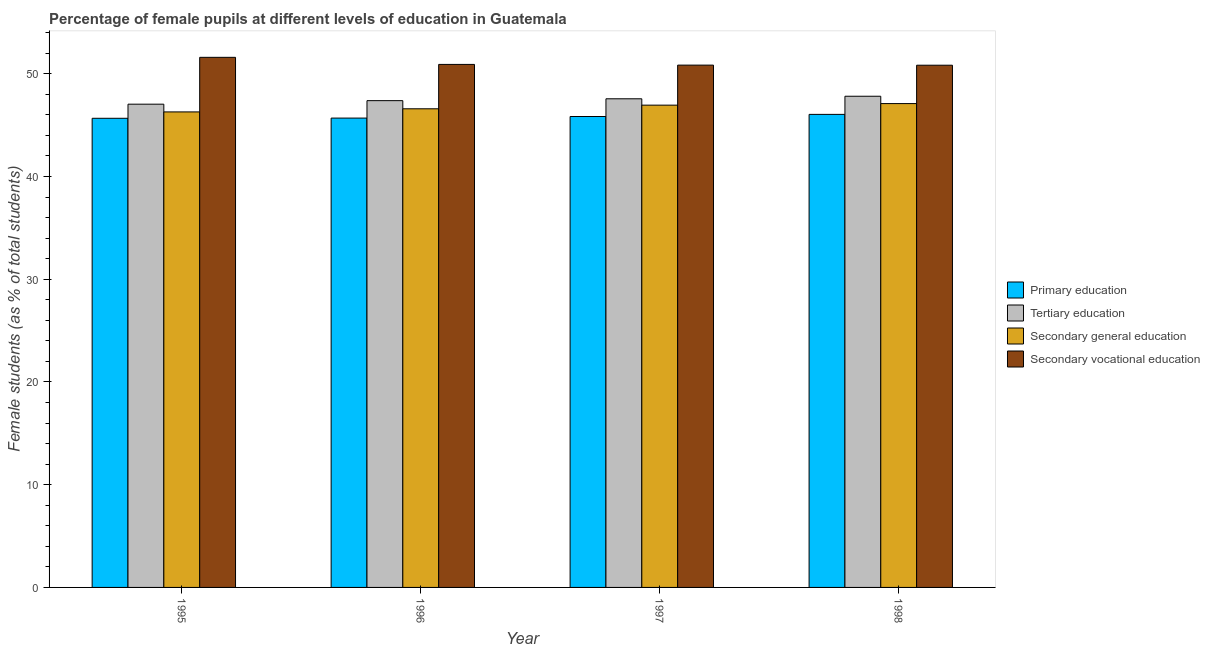How many different coloured bars are there?
Make the answer very short. 4. How many groups of bars are there?
Provide a succinct answer. 4. Are the number of bars on each tick of the X-axis equal?
Provide a short and direct response. Yes. How many bars are there on the 1st tick from the left?
Give a very brief answer. 4. What is the label of the 4th group of bars from the left?
Offer a terse response. 1998. In how many cases, is the number of bars for a given year not equal to the number of legend labels?
Provide a short and direct response. 0. What is the percentage of female students in primary education in 1997?
Ensure brevity in your answer.  45.84. Across all years, what is the maximum percentage of female students in secondary vocational education?
Ensure brevity in your answer.  51.6. Across all years, what is the minimum percentage of female students in tertiary education?
Offer a very short reply. 47.04. In which year was the percentage of female students in primary education minimum?
Make the answer very short. 1995. What is the total percentage of female students in tertiary education in the graph?
Ensure brevity in your answer.  189.8. What is the difference between the percentage of female students in tertiary education in 1995 and that in 1996?
Ensure brevity in your answer.  -0.34. What is the difference between the percentage of female students in secondary education in 1995 and the percentage of female students in tertiary education in 1996?
Ensure brevity in your answer.  -0.3. What is the average percentage of female students in primary education per year?
Your response must be concise. 45.81. In how many years, is the percentage of female students in tertiary education greater than 42 %?
Your answer should be very brief. 4. What is the ratio of the percentage of female students in secondary vocational education in 1995 to that in 1997?
Your answer should be very brief. 1.01. Is the difference between the percentage of female students in tertiary education in 1995 and 1996 greater than the difference between the percentage of female students in secondary vocational education in 1995 and 1996?
Your response must be concise. No. What is the difference between the highest and the second highest percentage of female students in secondary education?
Your answer should be compact. 0.15. What is the difference between the highest and the lowest percentage of female students in primary education?
Your response must be concise. 0.38. In how many years, is the percentage of female students in secondary vocational education greater than the average percentage of female students in secondary vocational education taken over all years?
Ensure brevity in your answer.  1. Is it the case that in every year, the sum of the percentage of female students in secondary vocational education and percentage of female students in tertiary education is greater than the sum of percentage of female students in primary education and percentage of female students in secondary education?
Offer a terse response. Yes. What does the 1st bar from the left in 1997 represents?
Offer a terse response. Primary education. What does the 1st bar from the right in 1998 represents?
Provide a succinct answer. Secondary vocational education. What is the difference between two consecutive major ticks on the Y-axis?
Provide a short and direct response. 10. Does the graph contain any zero values?
Provide a short and direct response. No. How many legend labels are there?
Offer a very short reply. 4. How are the legend labels stacked?
Your answer should be compact. Vertical. What is the title of the graph?
Ensure brevity in your answer.  Percentage of female pupils at different levels of education in Guatemala. What is the label or title of the Y-axis?
Give a very brief answer. Female students (as % of total students). What is the Female students (as % of total students) in Primary education in 1995?
Your answer should be compact. 45.67. What is the Female students (as % of total students) in Tertiary education in 1995?
Provide a short and direct response. 47.04. What is the Female students (as % of total students) of Secondary general education in 1995?
Your answer should be very brief. 46.29. What is the Female students (as % of total students) of Secondary vocational education in 1995?
Provide a succinct answer. 51.6. What is the Female students (as % of total students) of Primary education in 1996?
Offer a terse response. 45.69. What is the Female students (as % of total students) of Tertiary education in 1996?
Offer a terse response. 47.38. What is the Female students (as % of total students) of Secondary general education in 1996?
Your answer should be very brief. 46.59. What is the Female students (as % of total students) of Secondary vocational education in 1996?
Your answer should be very brief. 50.91. What is the Female students (as % of total students) in Primary education in 1997?
Make the answer very short. 45.84. What is the Female students (as % of total students) of Tertiary education in 1997?
Offer a very short reply. 47.57. What is the Female students (as % of total students) of Secondary general education in 1997?
Ensure brevity in your answer.  46.95. What is the Female students (as % of total students) in Secondary vocational education in 1997?
Your answer should be very brief. 50.84. What is the Female students (as % of total students) of Primary education in 1998?
Give a very brief answer. 46.05. What is the Female students (as % of total students) of Tertiary education in 1998?
Your answer should be compact. 47.81. What is the Female students (as % of total students) of Secondary general education in 1998?
Keep it short and to the point. 47.1. What is the Female students (as % of total students) of Secondary vocational education in 1998?
Ensure brevity in your answer.  50.83. Across all years, what is the maximum Female students (as % of total students) of Primary education?
Make the answer very short. 46.05. Across all years, what is the maximum Female students (as % of total students) in Tertiary education?
Keep it short and to the point. 47.81. Across all years, what is the maximum Female students (as % of total students) of Secondary general education?
Your answer should be very brief. 47.1. Across all years, what is the maximum Female students (as % of total students) in Secondary vocational education?
Offer a very short reply. 51.6. Across all years, what is the minimum Female students (as % of total students) in Primary education?
Your answer should be very brief. 45.67. Across all years, what is the minimum Female students (as % of total students) of Tertiary education?
Provide a short and direct response. 47.04. Across all years, what is the minimum Female students (as % of total students) of Secondary general education?
Offer a terse response. 46.29. Across all years, what is the minimum Female students (as % of total students) of Secondary vocational education?
Provide a short and direct response. 50.83. What is the total Female students (as % of total students) in Primary education in the graph?
Keep it short and to the point. 183.24. What is the total Female students (as % of total students) of Tertiary education in the graph?
Your answer should be very brief. 189.8. What is the total Female students (as % of total students) in Secondary general education in the graph?
Your response must be concise. 186.93. What is the total Female students (as % of total students) in Secondary vocational education in the graph?
Offer a very short reply. 204.19. What is the difference between the Female students (as % of total students) of Primary education in 1995 and that in 1996?
Your answer should be very brief. -0.02. What is the difference between the Female students (as % of total students) in Tertiary education in 1995 and that in 1996?
Make the answer very short. -0.34. What is the difference between the Female students (as % of total students) of Secondary general education in 1995 and that in 1996?
Provide a succinct answer. -0.3. What is the difference between the Female students (as % of total students) of Secondary vocational education in 1995 and that in 1996?
Offer a terse response. 0.69. What is the difference between the Female students (as % of total students) of Primary education in 1995 and that in 1997?
Your response must be concise. -0.17. What is the difference between the Female students (as % of total students) in Tertiary education in 1995 and that in 1997?
Keep it short and to the point. -0.52. What is the difference between the Female students (as % of total students) in Secondary general education in 1995 and that in 1997?
Offer a very short reply. -0.66. What is the difference between the Female students (as % of total students) in Secondary vocational education in 1995 and that in 1997?
Provide a short and direct response. 0.76. What is the difference between the Female students (as % of total students) of Primary education in 1995 and that in 1998?
Provide a succinct answer. -0.38. What is the difference between the Female students (as % of total students) in Tertiary education in 1995 and that in 1998?
Give a very brief answer. -0.77. What is the difference between the Female students (as % of total students) of Secondary general education in 1995 and that in 1998?
Offer a terse response. -0.81. What is the difference between the Female students (as % of total students) in Secondary vocational education in 1995 and that in 1998?
Offer a very short reply. 0.77. What is the difference between the Female students (as % of total students) of Primary education in 1996 and that in 1997?
Your response must be concise. -0.15. What is the difference between the Female students (as % of total students) in Tertiary education in 1996 and that in 1997?
Make the answer very short. -0.18. What is the difference between the Female students (as % of total students) in Secondary general education in 1996 and that in 1997?
Offer a very short reply. -0.35. What is the difference between the Female students (as % of total students) of Secondary vocational education in 1996 and that in 1997?
Give a very brief answer. 0.07. What is the difference between the Female students (as % of total students) of Primary education in 1996 and that in 1998?
Give a very brief answer. -0.36. What is the difference between the Female students (as % of total students) of Tertiary education in 1996 and that in 1998?
Ensure brevity in your answer.  -0.43. What is the difference between the Female students (as % of total students) of Secondary general education in 1996 and that in 1998?
Provide a short and direct response. -0.51. What is the difference between the Female students (as % of total students) in Secondary vocational education in 1996 and that in 1998?
Give a very brief answer. 0.08. What is the difference between the Female students (as % of total students) of Primary education in 1997 and that in 1998?
Offer a terse response. -0.21. What is the difference between the Female students (as % of total students) of Tertiary education in 1997 and that in 1998?
Give a very brief answer. -0.25. What is the difference between the Female students (as % of total students) in Secondary general education in 1997 and that in 1998?
Provide a short and direct response. -0.15. What is the difference between the Female students (as % of total students) of Secondary vocational education in 1997 and that in 1998?
Keep it short and to the point. 0.01. What is the difference between the Female students (as % of total students) in Primary education in 1995 and the Female students (as % of total students) in Tertiary education in 1996?
Offer a terse response. -1.72. What is the difference between the Female students (as % of total students) of Primary education in 1995 and the Female students (as % of total students) of Secondary general education in 1996?
Your response must be concise. -0.93. What is the difference between the Female students (as % of total students) of Primary education in 1995 and the Female students (as % of total students) of Secondary vocational education in 1996?
Keep it short and to the point. -5.24. What is the difference between the Female students (as % of total students) of Tertiary education in 1995 and the Female students (as % of total students) of Secondary general education in 1996?
Offer a terse response. 0.45. What is the difference between the Female students (as % of total students) of Tertiary education in 1995 and the Female students (as % of total students) of Secondary vocational education in 1996?
Give a very brief answer. -3.87. What is the difference between the Female students (as % of total students) of Secondary general education in 1995 and the Female students (as % of total students) of Secondary vocational education in 1996?
Make the answer very short. -4.62. What is the difference between the Female students (as % of total students) of Primary education in 1995 and the Female students (as % of total students) of Tertiary education in 1997?
Make the answer very short. -1.9. What is the difference between the Female students (as % of total students) in Primary education in 1995 and the Female students (as % of total students) in Secondary general education in 1997?
Provide a succinct answer. -1.28. What is the difference between the Female students (as % of total students) of Primary education in 1995 and the Female students (as % of total students) of Secondary vocational education in 1997?
Ensure brevity in your answer.  -5.18. What is the difference between the Female students (as % of total students) in Tertiary education in 1995 and the Female students (as % of total students) in Secondary general education in 1997?
Give a very brief answer. 0.09. What is the difference between the Female students (as % of total students) in Tertiary education in 1995 and the Female students (as % of total students) in Secondary vocational education in 1997?
Your response must be concise. -3.8. What is the difference between the Female students (as % of total students) in Secondary general education in 1995 and the Female students (as % of total students) in Secondary vocational education in 1997?
Your answer should be compact. -4.56. What is the difference between the Female students (as % of total students) of Primary education in 1995 and the Female students (as % of total students) of Tertiary education in 1998?
Ensure brevity in your answer.  -2.15. What is the difference between the Female students (as % of total students) in Primary education in 1995 and the Female students (as % of total students) in Secondary general education in 1998?
Ensure brevity in your answer.  -1.43. What is the difference between the Female students (as % of total students) in Primary education in 1995 and the Female students (as % of total students) in Secondary vocational education in 1998?
Your answer should be compact. -5.17. What is the difference between the Female students (as % of total students) in Tertiary education in 1995 and the Female students (as % of total students) in Secondary general education in 1998?
Make the answer very short. -0.06. What is the difference between the Female students (as % of total students) in Tertiary education in 1995 and the Female students (as % of total students) in Secondary vocational education in 1998?
Give a very brief answer. -3.79. What is the difference between the Female students (as % of total students) of Secondary general education in 1995 and the Female students (as % of total students) of Secondary vocational education in 1998?
Give a very brief answer. -4.55. What is the difference between the Female students (as % of total students) in Primary education in 1996 and the Female students (as % of total students) in Tertiary education in 1997?
Give a very brief answer. -1.88. What is the difference between the Female students (as % of total students) of Primary education in 1996 and the Female students (as % of total students) of Secondary general education in 1997?
Provide a succinct answer. -1.26. What is the difference between the Female students (as % of total students) of Primary education in 1996 and the Female students (as % of total students) of Secondary vocational education in 1997?
Keep it short and to the point. -5.16. What is the difference between the Female students (as % of total students) of Tertiary education in 1996 and the Female students (as % of total students) of Secondary general education in 1997?
Offer a terse response. 0.44. What is the difference between the Female students (as % of total students) of Tertiary education in 1996 and the Female students (as % of total students) of Secondary vocational education in 1997?
Keep it short and to the point. -3.46. What is the difference between the Female students (as % of total students) of Secondary general education in 1996 and the Female students (as % of total students) of Secondary vocational education in 1997?
Offer a terse response. -4.25. What is the difference between the Female students (as % of total students) of Primary education in 1996 and the Female students (as % of total students) of Tertiary education in 1998?
Your response must be concise. -2.13. What is the difference between the Female students (as % of total students) in Primary education in 1996 and the Female students (as % of total students) in Secondary general education in 1998?
Ensure brevity in your answer.  -1.41. What is the difference between the Female students (as % of total students) in Primary education in 1996 and the Female students (as % of total students) in Secondary vocational education in 1998?
Ensure brevity in your answer.  -5.15. What is the difference between the Female students (as % of total students) of Tertiary education in 1996 and the Female students (as % of total students) of Secondary general education in 1998?
Ensure brevity in your answer.  0.29. What is the difference between the Female students (as % of total students) in Tertiary education in 1996 and the Female students (as % of total students) in Secondary vocational education in 1998?
Make the answer very short. -3.45. What is the difference between the Female students (as % of total students) of Secondary general education in 1996 and the Female students (as % of total students) of Secondary vocational education in 1998?
Your answer should be compact. -4.24. What is the difference between the Female students (as % of total students) of Primary education in 1997 and the Female students (as % of total students) of Tertiary education in 1998?
Your response must be concise. -1.97. What is the difference between the Female students (as % of total students) in Primary education in 1997 and the Female students (as % of total students) in Secondary general education in 1998?
Make the answer very short. -1.26. What is the difference between the Female students (as % of total students) in Primary education in 1997 and the Female students (as % of total students) in Secondary vocational education in 1998?
Offer a very short reply. -4.99. What is the difference between the Female students (as % of total students) of Tertiary education in 1997 and the Female students (as % of total students) of Secondary general education in 1998?
Your response must be concise. 0.47. What is the difference between the Female students (as % of total students) in Tertiary education in 1997 and the Female students (as % of total students) in Secondary vocational education in 1998?
Your response must be concise. -3.27. What is the difference between the Female students (as % of total students) of Secondary general education in 1997 and the Female students (as % of total students) of Secondary vocational education in 1998?
Ensure brevity in your answer.  -3.89. What is the average Female students (as % of total students) of Primary education per year?
Give a very brief answer. 45.81. What is the average Female students (as % of total students) in Tertiary education per year?
Your answer should be compact. 47.45. What is the average Female students (as % of total students) in Secondary general education per year?
Keep it short and to the point. 46.73. What is the average Female students (as % of total students) of Secondary vocational education per year?
Offer a terse response. 51.05. In the year 1995, what is the difference between the Female students (as % of total students) in Primary education and Female students (as % of total students) in Tertiary education?
Offer a terse response. -1.37. In the year 1995, what is the difference between the Female students (as % of total students) of Primary education and Female students (as % of total students) of Secondary general education?
Provide a succinct answer. -0.62. In the year 1995, what is the difference between the Female students (as % of total students) of Primary education and Female students (as % of total students) of Secondary vocational education?
Make the answer very short. -5.93. In the year 1995, what is the difference between the Female students (as % of total students) in Tertiary education and Female students (as % of total students) in Secondary general education?
Keep it short and to the point. 0.75. In the year 1995, what is the difference between the Female students (as % of total students) of Tertiary education and Female students (as % of total students) of Secondary vocational education?
Keep it short and to the point. -4.56. In the year 1995, what is the difference between the Female students (as % of total students) of Secondary general education and Female students (as % of total students) of Secondary vocational education?
Offer a terse response. -5.31. In the year 1996, what is the difference between the Female students (as % of total students) in Primary education and Female students (as % of total students) in Tertiary education?
Provide a succinct answer. -1.7. In the year 1996, what is the difference between the Female students (as % of total students) in Primary education and Female students (as % of total students) in Secondary general education?
Give a very brief answer. -0.9. In the year 1996, what is the difference between the Female students (as % of total students) in Primary education and Female students (as % of total students) in Secondary vocational education?
Provide a succinct answer. -5.22. In the year 1996, what is the difference between the Female students (as % of total students) of Tertiary education and Female students (as % of total students) of Secondary general education?
Keep it short and to the point. 0.79. In the year 1996, what is the difference between the Female students (as % of total students) in Tertiary education and Female students (as % of total students) in Secondary vocational education?
Your answer should be very brief. -3.53. In the year 1996, what is the difference between the Female students (as % of total students) of Secondary general education and Female students (as % of total students) of Secondary vocational education?
Keep it short and to the point. -4.32. In the year 1997, what is the difference between the Female students (as % of total students) in Primary education and Female students (as % of total students) in Tertiary education?
Your answer should be compact. -1.73. In the year 1997, what is the difference between the Female students (as % of total students) in Primary education and Female students (as % of total students) in Secondary general education?
Provide a succinct answer. -1.11. In the year 1997, what is the difference between the Female students (as % of total students) of Primary education and Female students (as % of total students) of Secondary vocational education?
Give a very brief answer. -5. In the year 1997, what is the difference between the Female students (as % of total students) in Tertiary education and Female students (as % of total students) in Secondary general education?
Provide a short and direct response. 0.62. In the year 1997, what is the difference between the Female students (as % of total students) in Tertiary education and Female students (as % of total students) in Secondary vocational education?
Keep it short and to the point. -3.28. In the year 1997, what is the difference between the Female students (as % of total students) of Secondary general education and Female students (as % of total students) of Secondary vocational education?
Offer a very short reply. -3.9. In the year 1998, what is the difference between the Female students (as % of total students) in Primary education and Female students (as % of total students) in Tertiary education?
Offer a terse response. -1.77. In the year 1998, what is the difference between the Female students (as % of total students) in Primary education and Female students (as % of total students) in Secondary general education?
Your answer should be compact. -1.05. In the year 1998, what is the difference between the Female students (as % of total students) in Primary education and Female students (as % of total students) in Secondary vocational education?
Ensure brevity in your answer.  -4.79. In the year 1998, what is the difference between the Female students (as % of total students) in Tertiary education and Female students (as % of total students) in Secondary general education?
Your response must be concise. 0.71. In the year 1998, what is the difference between the Female students (as % of total students) of Tertiary education and Female students (as % of total students) of Secondary vocational education?
Ensure brevity in your answer.  -3.02. In the year 1998, what is the difference between the Female students (as % of total students) of Secondary general education and Female students (as % of total students) of Secondary vocational education?
Offer a terse response. -3.73. What is the ratio of the Female students (as % of total students) of Tertiary education in 1995 to that in 1996?
Offer a terse response. 0.99. What is the ratio of the Female students (as % of total students) of Secondary vocational education in 1995 to that in 1996?
Your answer should be compact. 1.01. What is the ratio of the Female students (as % of total students) of Primary education in 1995 to that in 1997?
Your response must be concise. 1. What is the ratio of the Female students (as % of total students) of Tertiary education in 1995 to that in 1997?
Your answer should be compact. 0.99. What is the ratio of the Female students (as % of total students) of Secondary vocational education in 1995 to that in 1997?
Offer a very short reply. 1.01. What is the ratio of the Female students (as % of total students) in Primary education in 1995 to that in 1998?
Make the answer very short. 0.99. What is the ratio of the Female students (as % of total students) in Tertiary education in 1995 to that in 1998?
Make the answer very short. 0.98. What is the ratio of the Female students (as % of total students) in Secondary general education in 1995 to that in 1998?
Provide a short and direct response. 0.98. What is the ratio of the Female students (as % of total students) of Secondary vocational education in 1995 to that in 1998?
Offer a very short reply. 1.02. What is the ratio of the Female students (as % of total students) in Tertiary education in 1996 to that in 1997?
Your response must be concise. 1. What is the ratio of the Female students (as % of total students) in Secondary vocational education in 1996 to that in 1997?
Keep it short and to the point. 1. What is the ratio of the Female students (as % of total students) of Primary education in 1996 to that in 1998?
Make the answer very short. 0.99. What is the ratio of the Female students (as % of total students) of Secondary general education in 1996 to that in 1998?
Your answer should be compact. 0.99. What is the difference between the highest and the second highest Female students (as % of total students) in Primary education?
Give a very brief answer. 0.21. What is the difference between the highest and the second highest Female students (as % of total students) in Tertiary education?
Offer a terse response. 0.25. What is the difference between the highest and the second highest Female students (as % of total students) of Secondary general education?
Make the answer very short. 0.15. What is the difference between the highest and the second highest Female students (as % of total students) of Secondary vocational education?
Offer a terse response. 0.69. What is the difference between the highest and the lowest Female students (as % of total students) in Primary education?
Ensure brevity in your answer.  0.38. What is the difference between the highest and the lowest Female students (as % of total students) in Tertiary education?
Give a very brief answer. 0.77. What is the difference between the highest and the lowest Female students (as % of total students) of Secondary general education?
Provide a short and direct response. 0.81. What is the difference between the highest and the lowest Female students (as % of total students) in Secondary vocational education?
Ensure brevity in your answer.  0.77. 